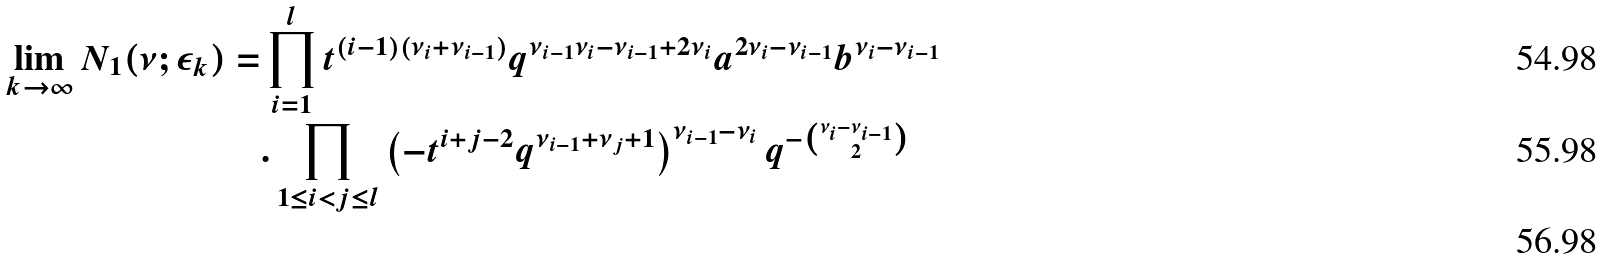Convert formula to latex. <formula><loc_0><loc_0><loc_500><loc_500>\lim _ { k \rightarrow \infty } N _ { 1 } ( \nu ; \epsilon _ { k } ) = & \prod _ { i = 1 } ^ { l } t ^ { ( i - 1 ) ( \nu _ { i } + \nu _ { i - 1 } ) } q ^ { \nu _ { i - 1 } \nu _ { i } - \nu _ { i - 1 } + 2 \nu _ { i } } a ^ { 2 \nu _ { i } - \nu _ { i - 1 } } b ^ { \nu _ { i } - \nu _ { i - 1 } } \\ & . \prod _ { 1 \leq i < j \leq l } \left ( - t ^ { i + j - 2 } q ^ { \nu _ { i - 1 } + \nu _ { j } + 1 } \right ) ^ { \nu _ { i - 1 } - \nu _ { i } } q ^ { - \binom { \nu _ { i } - \nu _ { i - 1 } } { 2 } } \\</formula> 